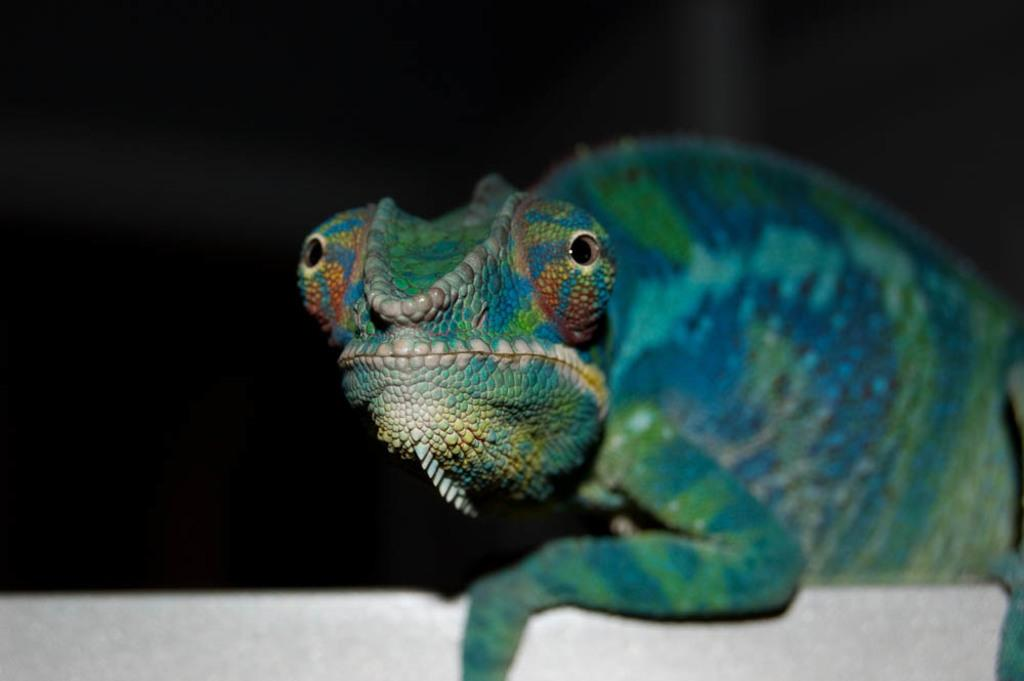What type of animal is in the image? There is a chameleon in the image. What can be observed about the background of the image? The background of the image is dark. What is the chameleon attempting to increase in the image? There is no indication in the image that the chameleon is attempting to increase anything. 